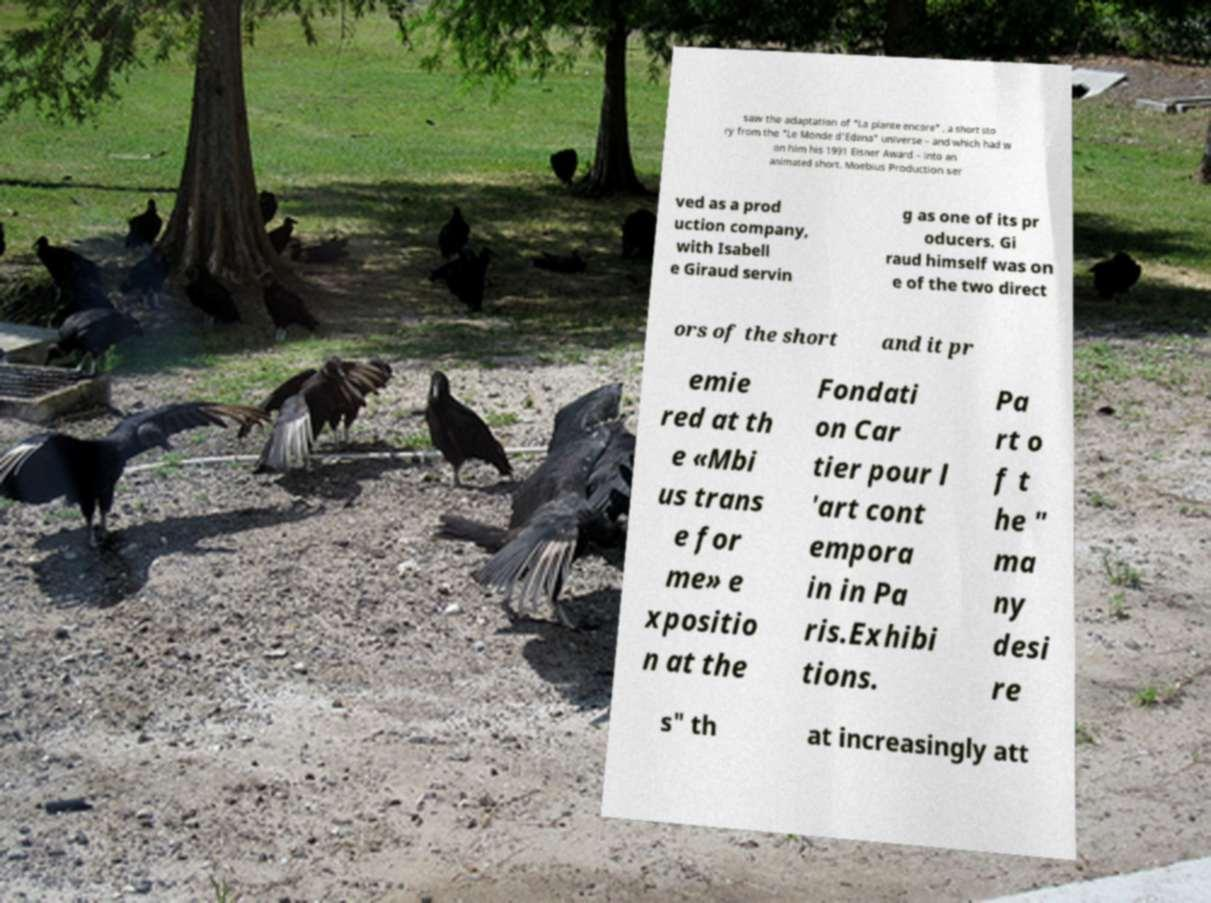Please identify and transcribe the text found in this image. saw the adaptation of "La plante encore" , a short sto ry from the "Le Monde d'Edena" universe – and which had w on him his 1991 Eisner Award – into an animated short. Moebius Production ser ved as a prod uction company, with Isabell e Giraud servin g as one of its pr oducers. Gi raud himself was on e of the two direct ors of the short and it pr emie red at th e «Mbi us trans e for me» e xpositio n at the Fondati on Car tier pour l 'art cont empora in in Pa ris.Exhibi tions. Pa rt o f t he " ma ny desi re s" th at increasingly att 